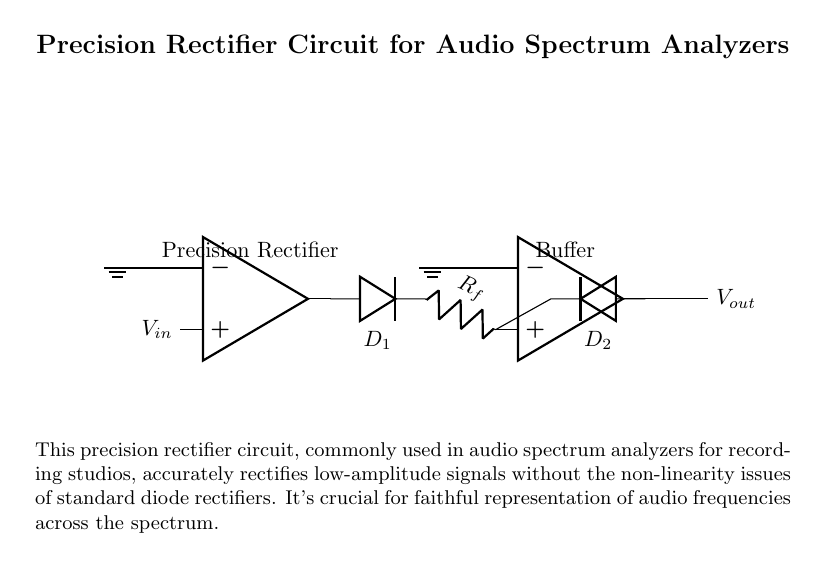What is the input voltage of this circuit? The input voltage, represented by `V_in`, refers to the signal entering the precision rectifier circuit. It is marked on the diagram next to the op-amp.
Answer: V_in What are the diodes in this circuit? The diagram shows two diodes labeled `D_1` and `D_2` which are essential components of the precision rectifier circuit. `D_1` is positioned between the output of the first op-amp and the feedback resistor, while `D_2` connects to the output of the second op-amp.
Answer: D_1, D_2 What role does the second op-amp serve in this circuit? The second op-amp serves as a buffer. It ensures that the output voltage does not affect the circuit’s performance by providing high input impedance and low output impedance. This is indicated by the label "Buffer" above the op-amp.
Answer: Buffer Why is a precision rectifier used in audio applications? Precision rectifiers are necessary in audio applications because they accurately rectify low-amplitude signals without introducing non-linearity issues, essential for obtaining a faithful representation of audio frequencies. This is described in the explanation below the circuit.
Answer: Non-linearity issues What is the function of resistor `R_f` in this circuit? The resistor `R_f` serves as the feedback resistor for the first op-amp, influencing the gain of the circuit and the accuracy of the rectification process. Its presence is vital for controlling the output voltage relationship, as indicated in standard precision rectifier configurations.
Answer: Gain adjustment How does this circuit differ from a standard rectifier? This circuit differs from a standard rectifier by using operational amplifiers and diodes, which allow for accurate rectification of low-level signals, overcoming the limitations of conventional diode-only rectifiers that suffer from voltage drop and non-linearity. This is highlighted in the description section.
Answer: Accurate rectification What is the output voltage labeled as in this circuit? The output voltage is labeled as `V_out`, which is the voltage that appears at the output terminal after the rectification process. This label is clearly marked at the right side of the second op-amp.
Answer: V_out 